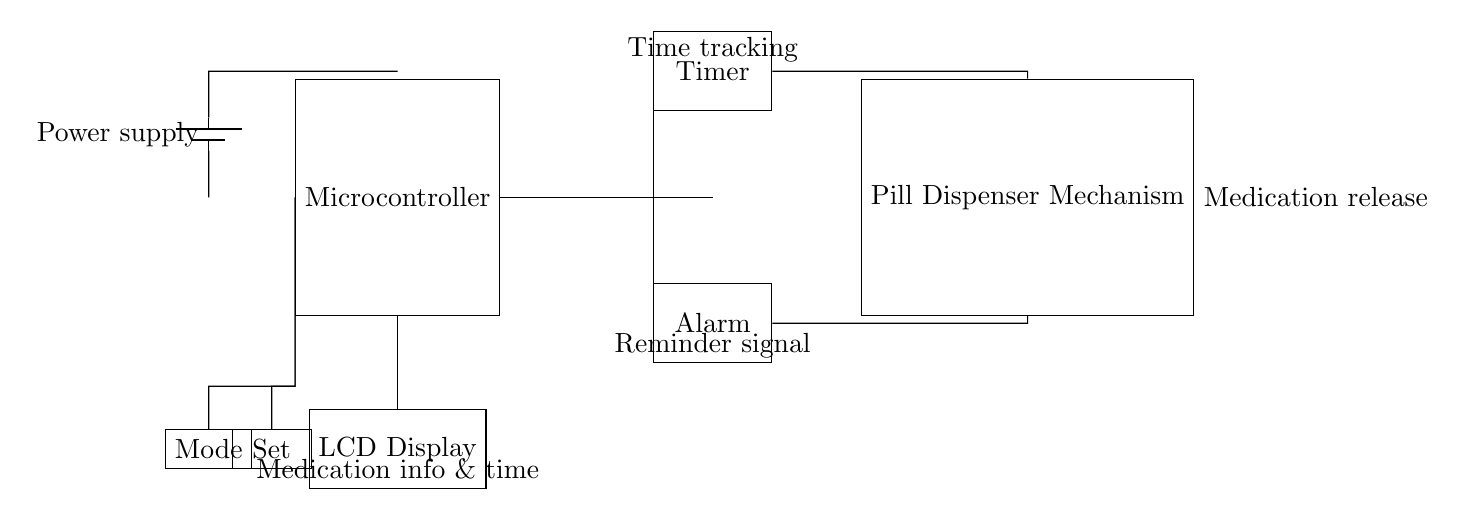What is the function of the microcontroller? The microcontroller coordinates the overall operation of the device, including managing the timer, alarm, and pill dispenser mechanism.
Answer: Coordination What connects the timer to the pill dispenser mechanism? The timer is connected to the pill dispenser mechanism through a direct link from its east side to the north side of the dispenser.
Answer: Connection How many buttons are present in the circuit? There are two buttons: one for setting the timer and one for changing the mode.
Answer: Two What component provides power to the circuit? The power supply is sourced from the battery located at the left side of the circuit diagram.
Answer: Battery Why is the alarm connected to the dispenser mechanism? The alarm is connected to the dispenser mechanism to activate it at the appropriate time, signaling when medication should be released.
Answer: Medication release timing What additional information is displayed on the LCD display? The LCD display shows medication information along with the scheduled times for dosage based on the timer settings.
Answer: Medication info and time 